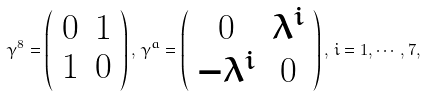<formula> <loc_0><loc_0><loc_500><loc_500>\gamma ^ { 8 } = \left ( \begin{array} { c c } 0 & 1 \\ 1 & 0 \end{array} \right ) , \, \gamma ^ { a } = \left ( \begin{array} { c c } 0 & \lambda ^ { i } \\ - \lambda ^ { i } & 0 \end{array} \right ) , \, i = 1 , \cdots , 7 ,</formula> 